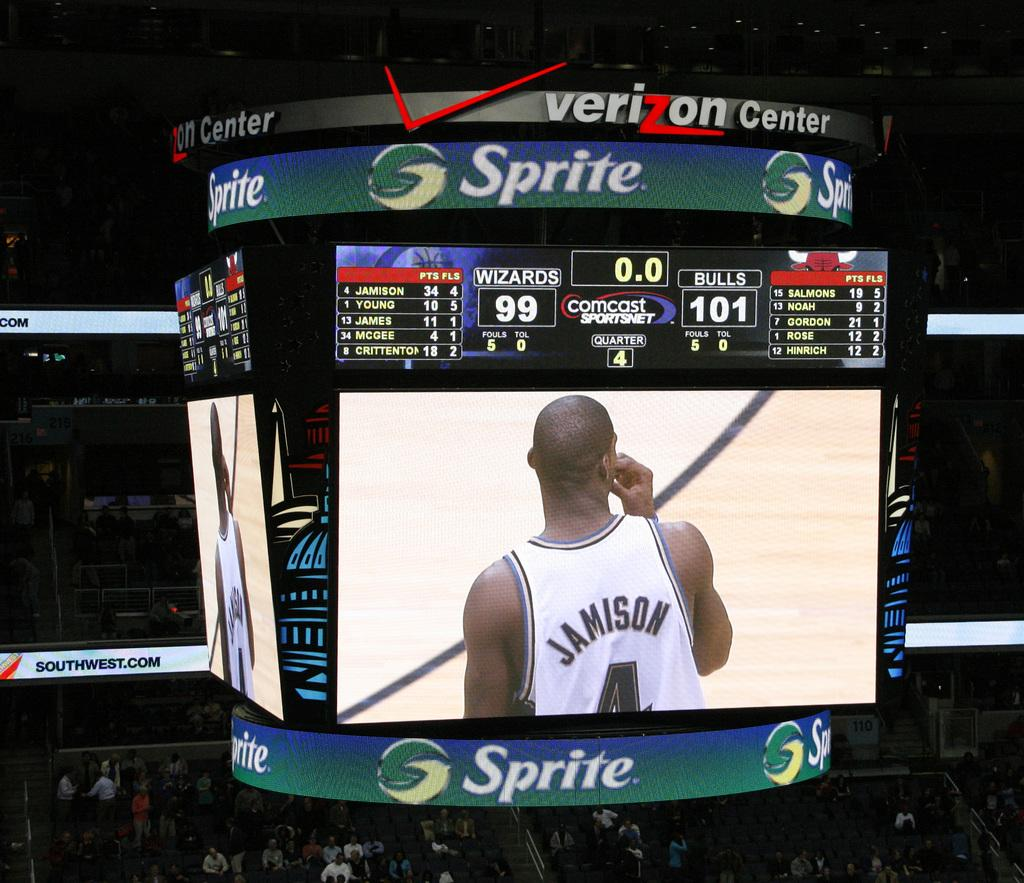<image>
Give a short and clear explanation of the subsequent image. Scoreboard in a stadium with a Sprite ad. 